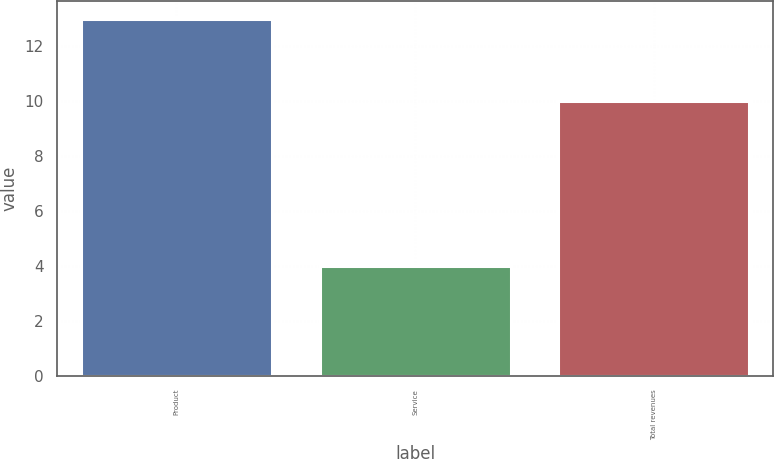Convert chart. <chart><loc_0><loc_0><loc_500><loc_500><bar_chart><fcel>Product<fcel>Service<fcel>Total revenues<nl><fcel>13<fcel>4<fcel>10<nl></chart> 